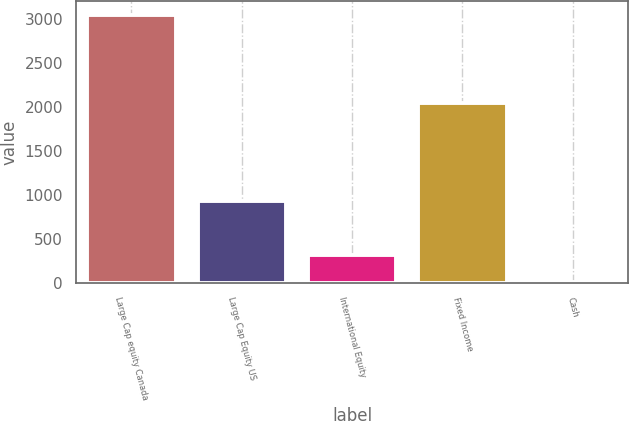Convert chart. <chart><loc_0><loc_0><loc_500><loc_500><bar_chart><fcel>Large Cap equity Canada<fcel>Large Cap Equity US<fcel>International Equity<fcel>Fixed Income<fcel>Cash<nl><fcel>3050<fcel>929<fcel>314<fcel>2040<fcel>10<nl></chart> 